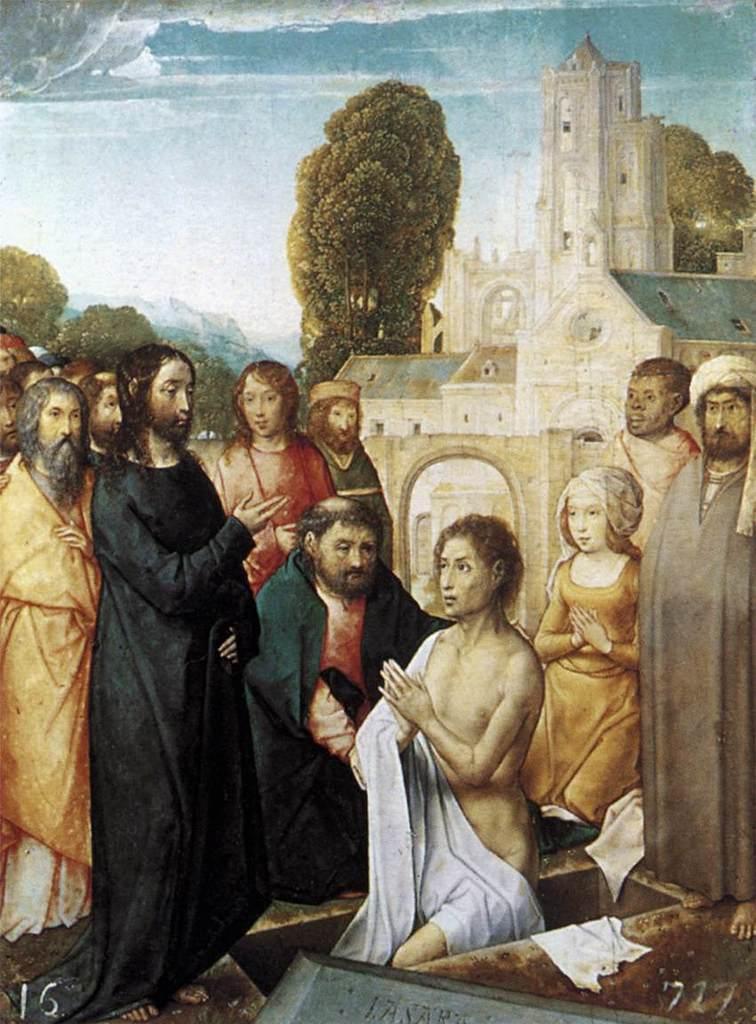Describe this image in one or two sentences. In this picture I can see a painting, there are group of people, there is a building, there are trees, and in the background there is the sky. 